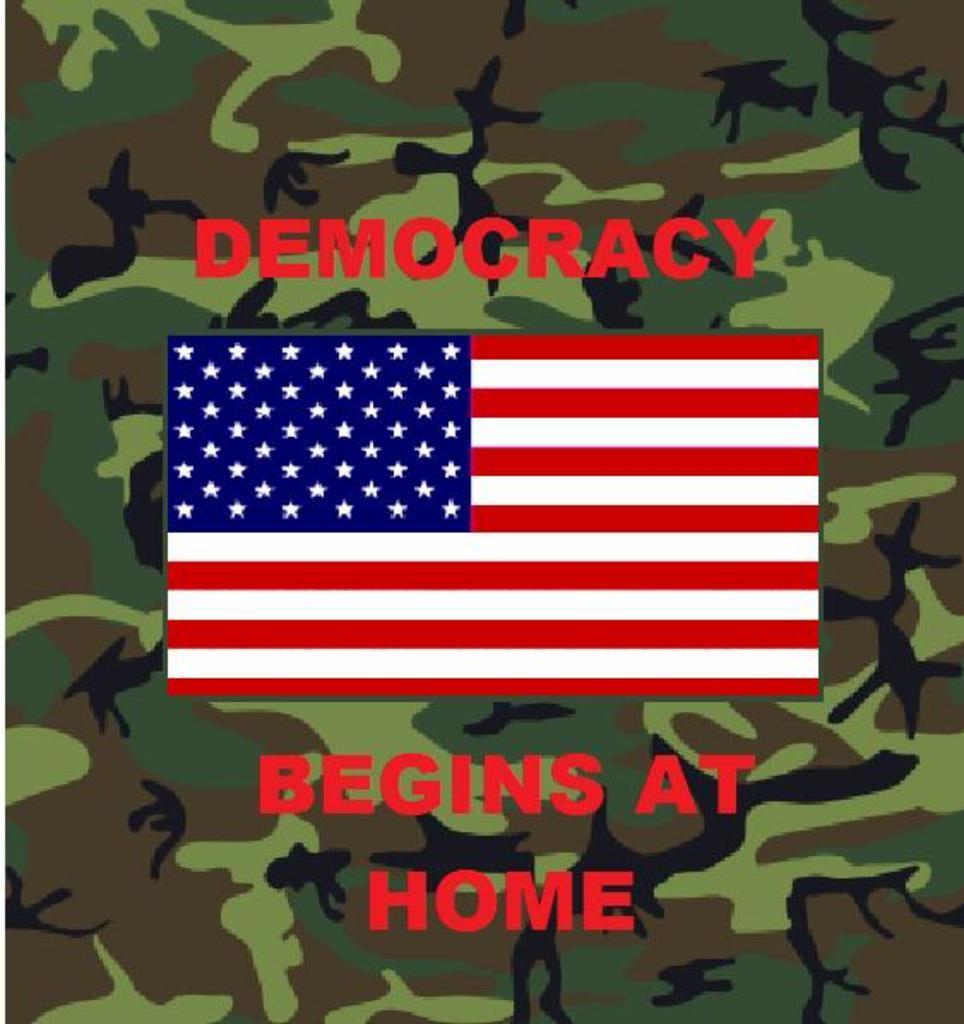Describe this image in one or two sentences. In the middle of the image we can see a flag and text on the top and bottom. 